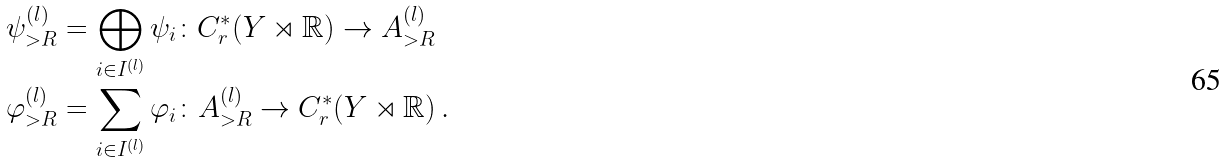<formula> <loc_0><loc_0><loc_500><loc_500>\psi _ { > R } ^ { ( l ) } & = \bigoplus _ { i \in I ^ { ( l ) } } \psi _ { i } \colon C ^ { * } _ { r } ( Y \rtimes \mathbb { R } ) \to A _ { > R } ^ { ( l ) } \\ \varphi _ { > R } ^ { ( l ) } & = \sum _ { i \in I ^ { ( l ) } } \varphi _ { i } \colon A _ { > R } ^ { ( l ) } \to C ^ { * } _ { r } ( Y \rtimes \mathbb { R } ) \, .</formula> 